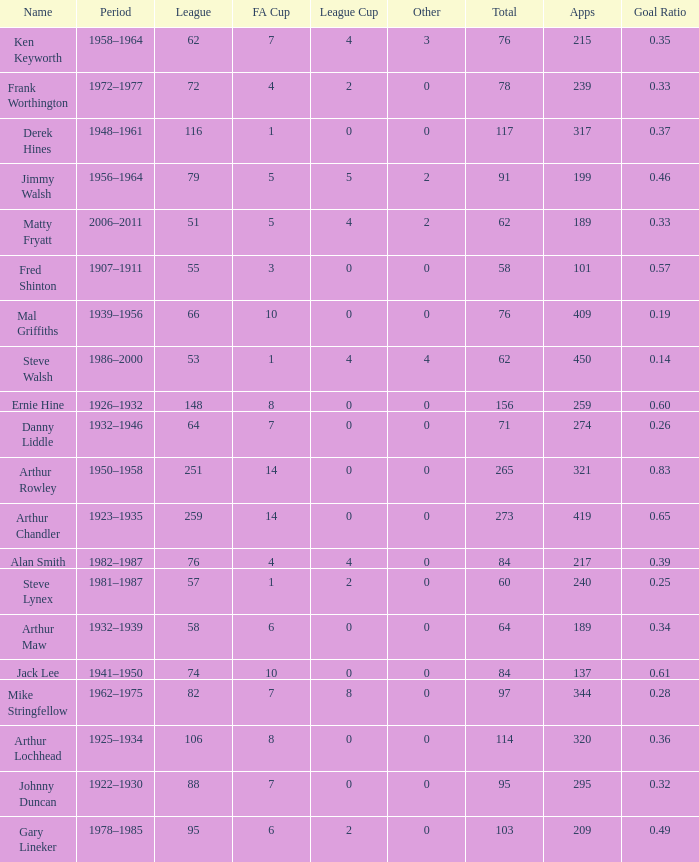What's the lowest Total thats got an FA Cup larger than 10, Name of Arthur Chandler, and a League Cup thats larger than 0? None. 